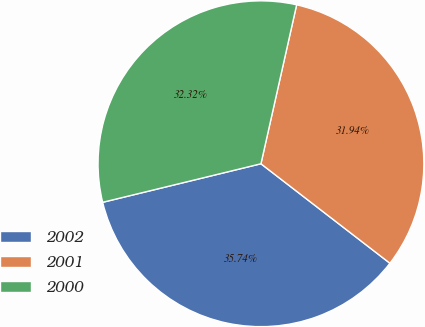Convert chart to OTSL. <chart><loc_0><loc_0><loc_500><loc_500><pie_chart><fcel>2002<fcel>2001<fcel>2000<nl><fcel>35.74%<fcel>31.94%<fcel>32.32%<nl></chart> 